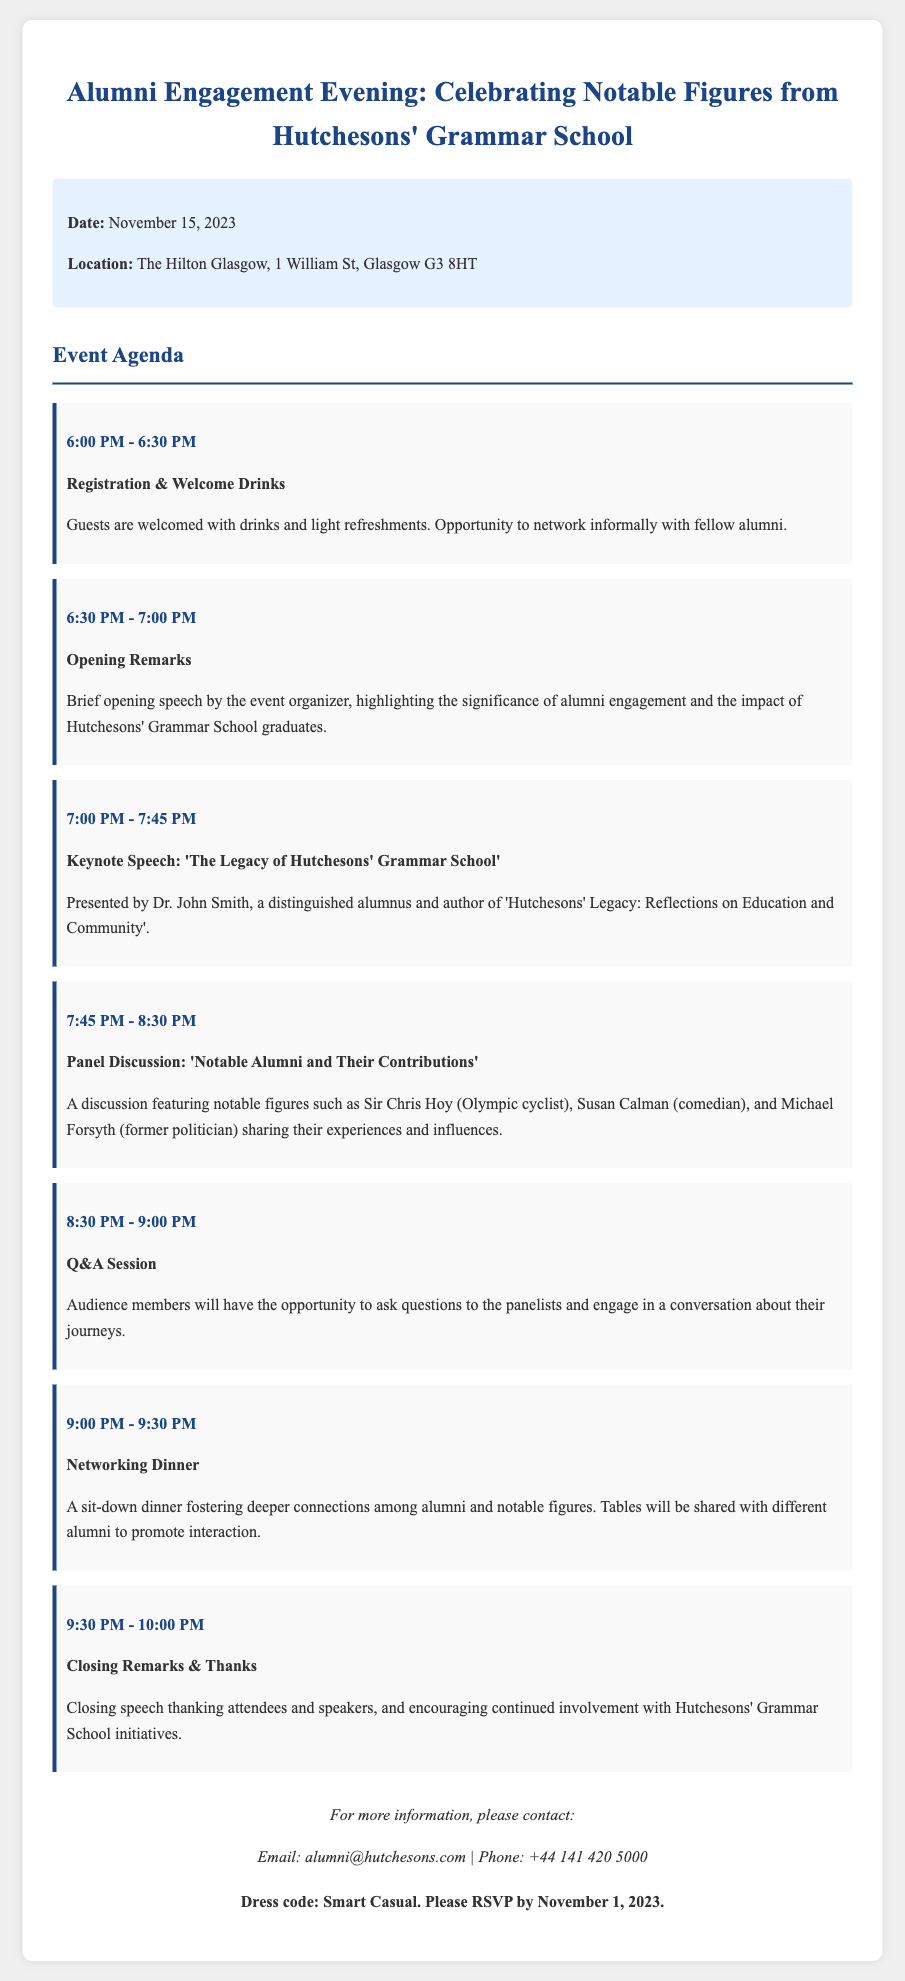What is the date of the event? The date of the event is explicitly mentioned in the event details section of the document.
Answer: November 15, 2023 Where is the Alumni Engagement Evening taking place? The location is specified in the event details.
Answer: The Hilton Glasgow, 1 William St, Glasgow G3 8HT Who is the speaker for the keynote speech? The keynote speech section names the speaker presenting the topic.
Answer: Dr. John Smith What time does the networking dinner start? The start time for the networking dinner is listed in the agenda items.
Answer: 9:00 PM Which notable figures are participating in the panel discussion? The panel discussion section lists the notable figures who will be presenting.
Answer: Sir Chris Hoy, Susan Calman, Michael Forsyth What is the dress code for the event? The dress code is mentioned at the end of the document.
Answer: Smart Casual How long is the Q&A session? The duration of the Q&A session can be determined by the times listed for that agenda item.
Answer: 30 minutes When is the RSVP deadline? The RSVP deadline is mentioned in the notes at the bottom of the document.
Answer: November 1, 2023 What is the primary focus of the opening remarks? The opening remarks section briefly describes its focus.
Answer: Significance of alumni engagement and the impact of Hutchesons' Grammar School graduates 